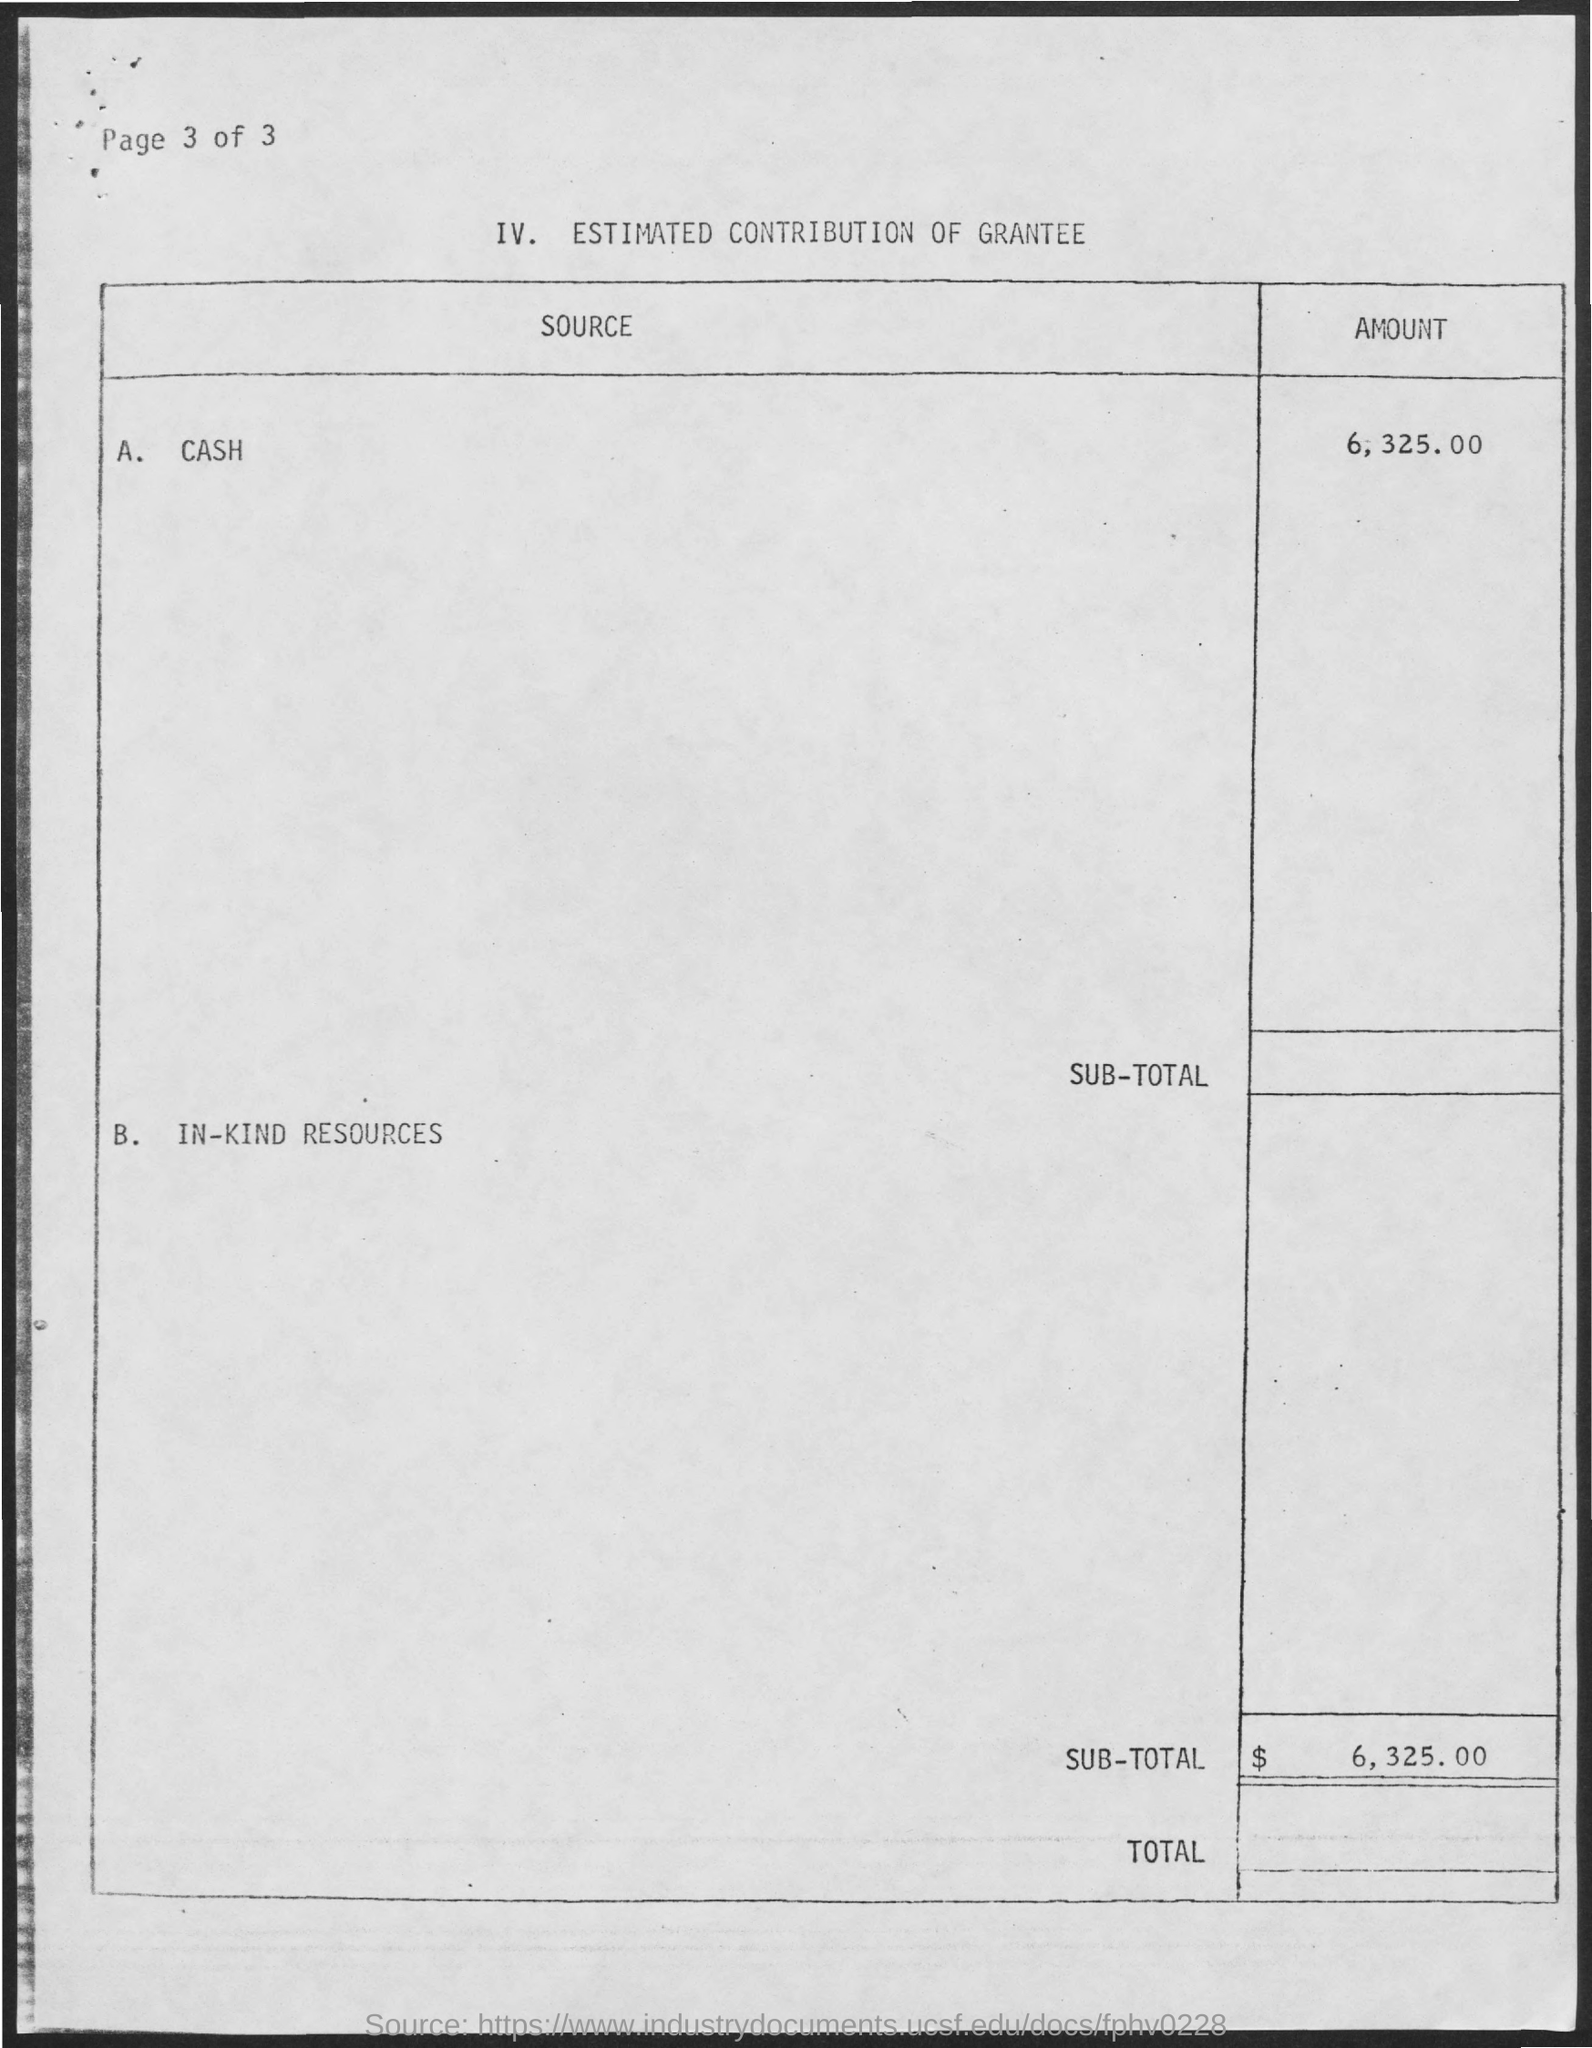What is the title of the table?
Offer a very short reply. ESTIMATED CONTRIBUTION OF GRANTEE. What is the  heading of first column of table?
Provide a succinct answer. SOURCE. What is the heading of second column of table?
Your answer should be very brief. AMOUNT. Mention first entry under "SOURCE" column?
Provide a short and direct response. CASH. Mention second entry under "SOURCE" column?
Your answer should be very brief. B.  IN-KIND RESOURCES. What is the "AMOUNT" given for "CASH"?
Make the answer very short. 6325.00. What is the "SUB-TOTAL" amount?
Provide a short and direct response. $  6,325.00. What is the "page" number given at the left top of the page?
Provide a short and direct response. Page 3 of 3. 